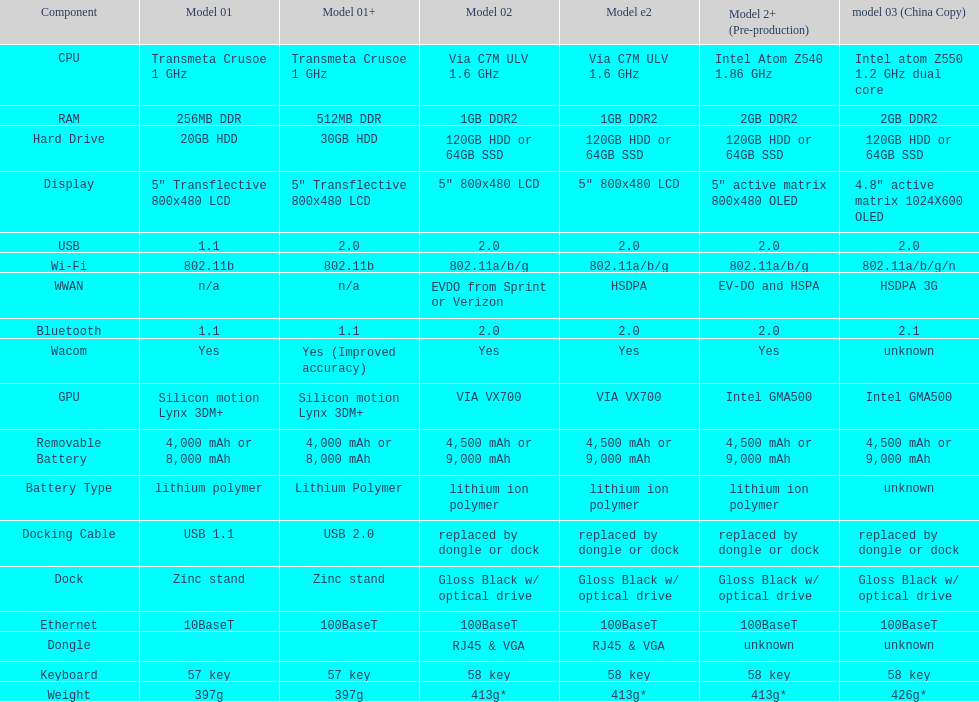What is the overall count of elements present in the diagram? 18. 